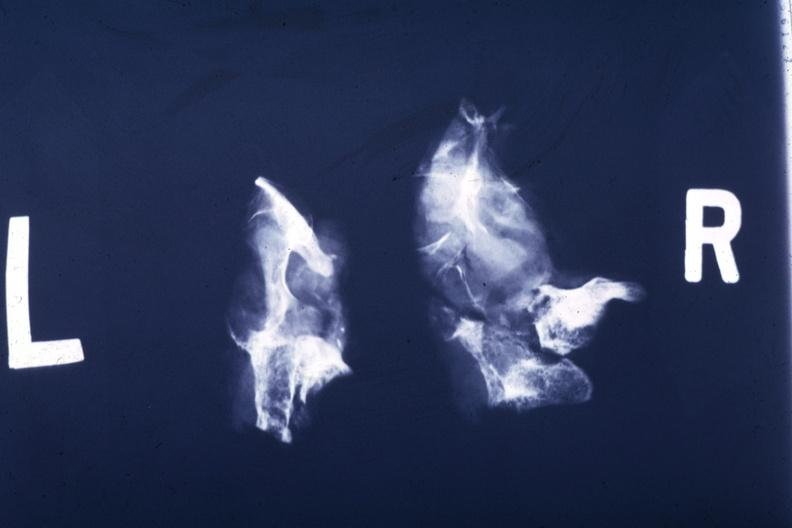does this x-ray of sella turcica after removal postmort show partially destroyed bone and large soft tissue mass?
Answer the question using a single word or phrase. Yes 